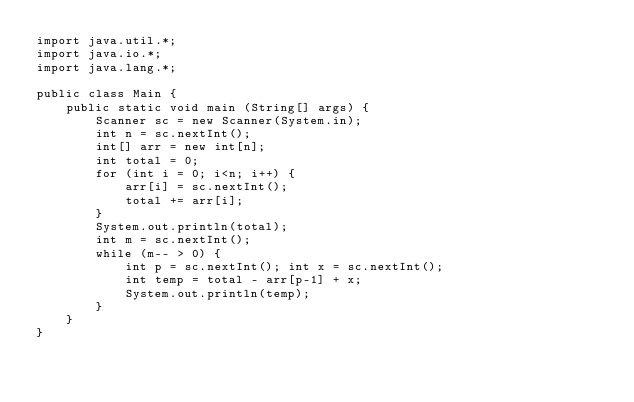<code> <loc_0><loc_0><loc_500><loc_500><_Java_>import java.util.*;
import java.io.*;
import java.lang.*;

public class Main {
	public static void main (String[] args) {
		Scanner sc = new Scanner(System.in);
		int n = sc.nextInt();
		int[] arr = new int[n];
		int total = 0;
		for (int i = 0; i<n; i++) {
			arr[i] = sc.nextInt(); 
			total += arr[i];	
		}
		System.out.println(total);
		int m = sc.nextInt();
		while (m-- > 0) {
			int p = sc.nextInt(); int x = sc.nextInt();
			int temp = total - arr[p-1] + x;
			System.out.println(temp);
		}
	}
}
</code> 